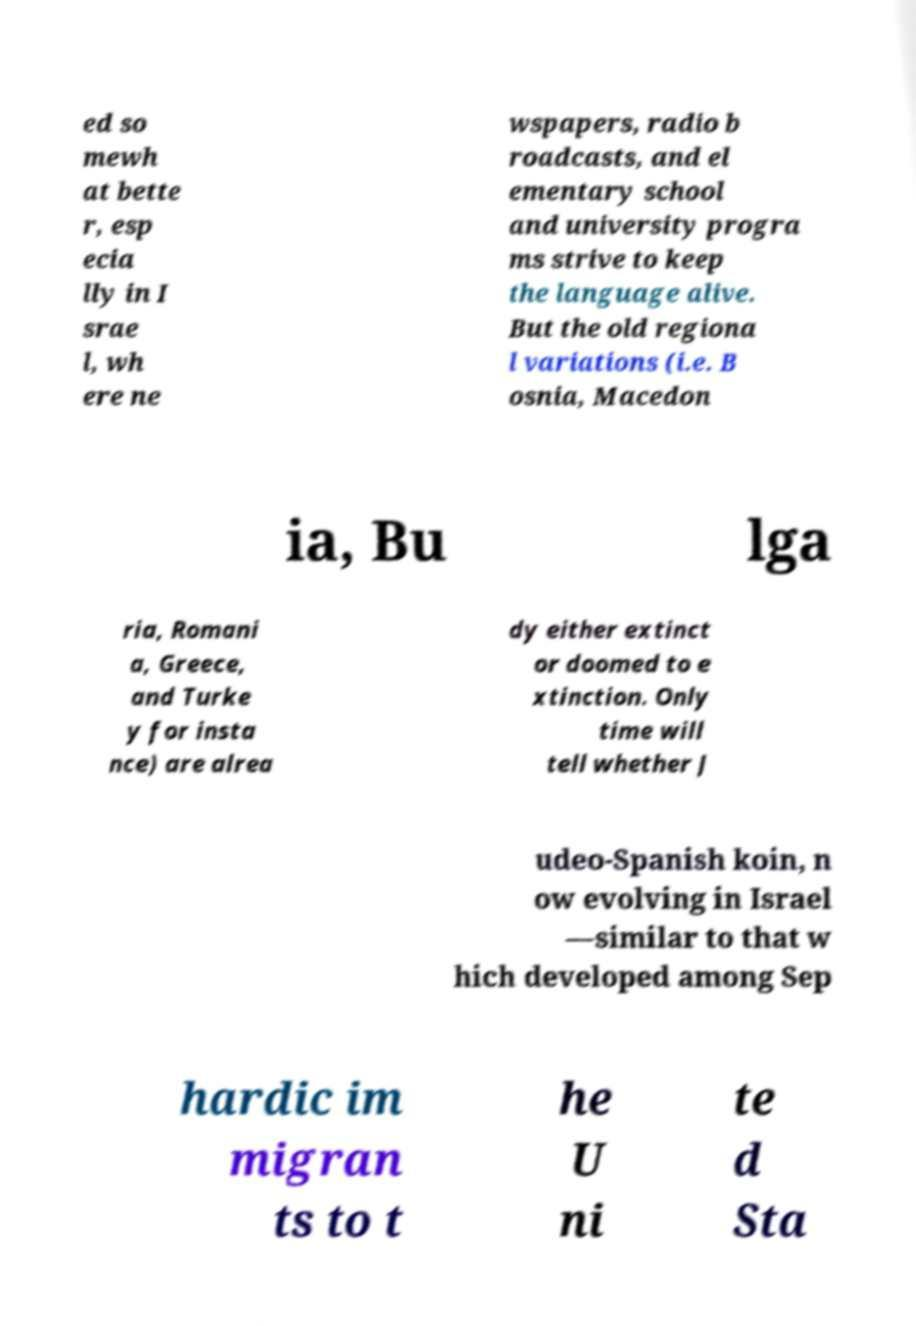Can you read and provide the text displayed in the image?This photo seems to have some interesting text. Can you extract and type it out for me? ed so mewh at bette r, esp ecia lly in I srae l, wh ere ne wspapers, radio b roadcasts, and el ementary school and university progra ms strive to keep the language alive. But the old regiona l variations (i.e. B osnia, Macedon ia, Bu lga ria, Romani a, Greece, and Turke y for insta nce) are alrea dy either extinct or doomed to e xtinction. Only time will tell whether J udeo-Spanish koin, n ow evolving in Israel —similar to that w hich developed among Sep hardic im migran ts to t he U ni te d Sta 